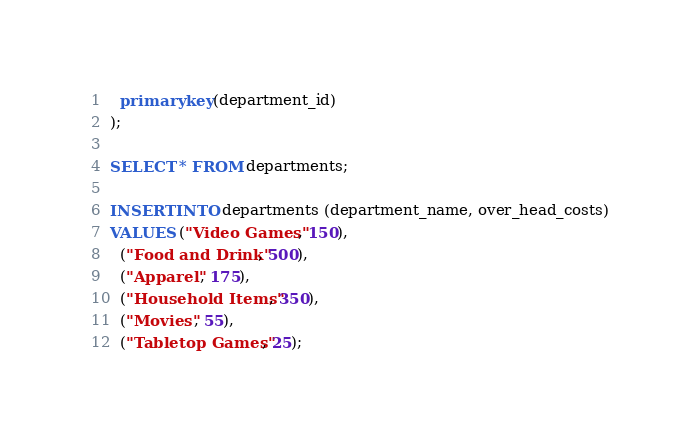Convert code to text. <code><loc_0><loc_0><loc_500><loc_500><_SQL_>  primary key(department_id)
);

SELECT * FROM departments;

INSERT INTO departments (department_name, over_head_costs)
VALUES ("Video Games", 150),
  ("Food and Drink", 500),
  ("Apparel", 175),
  ("Household Items", 350),
  ("Movies", 55),
  ("Tabletop Games", 25);
</code> 